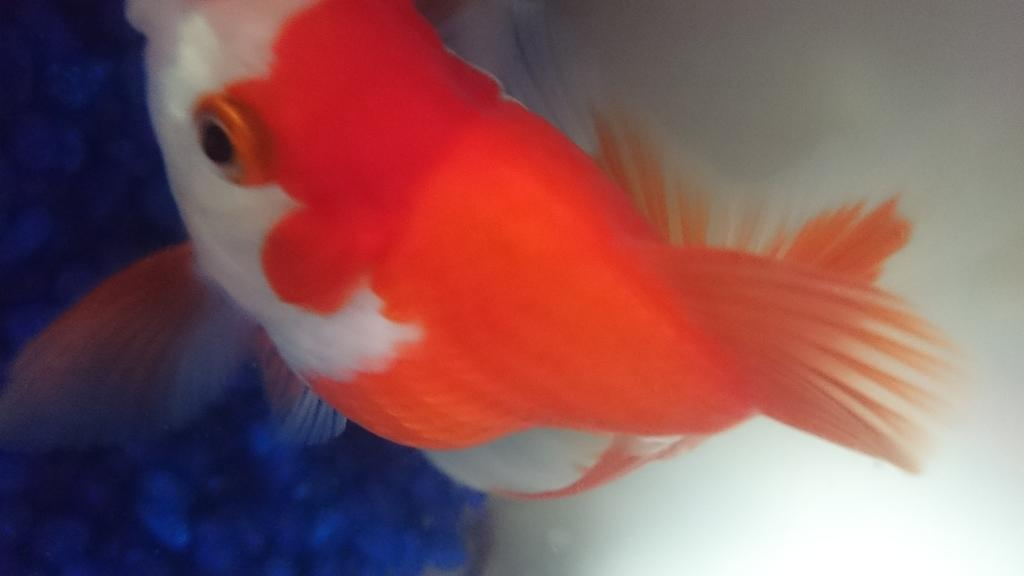What type of animal is present in the image? There is a goldfish in the image. Can you describe the appearance of the goldfish? The goldfish has a round body, fins, and a tail. What is the goldfish's habitat in the image? The goldfish is likely in an aquarium or a body of water. What type of creature is the goldfish taking on a trip in the image? There is no creature or trip present in the image; it only features a goldfish. 